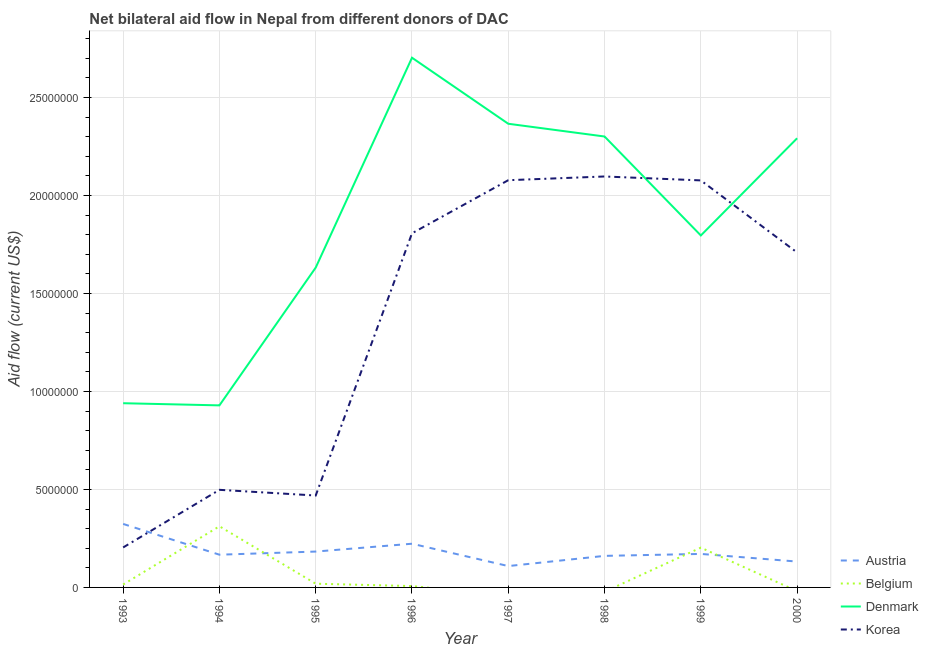How many different coloured lines are there?
Provide a succinct answer. 4. Does the line corresponding to amount of aid given by korea intersect with the line corresponding to amount of aid given by denmark?
Your answer should be compact. Yes. Is the number of lines equal to the number of legend labels?
Offer a terse response. No. What is the amount of aid given by korea in 1998?
Keep it short and to the point. 2.10e+07. Across all years, what is the maximum amount of aid given by belgium?
Provide a short and direct response. 3.12e+06. Across all years, what is the minimum amount of aid given by korea?
Make the answer very short. 2.04e+06. What is the total amount of aid given by austria in the graph?
Give a very brief answer. 1.47e+07. What is the difference between the amount of aid given by denmark in 1993 and that in 1999?
Your response must be concise. -8.56e+06. What is the difference between the amount of aid given by belgium in 1996 and the amount of aid given by austria in 1995?
Keep it short and to the point. -1.76e+06. What is the average amount of aid given by denmark per year?
Provide a succinct answer. 1.87e+07. In the year 1995, what is the difference between the amount of aid given by denmark and amount of aid given by austria?
Keep it short and to the point. 1.45e+07. What is the ratio of the amount of aid given by austria in 1998 to that in 2000?
Offer a very short reply. 1.22. Is the difference between the amount of aid given by denmark in 1998 and 1999 greater than the difference between the amount of aid given by austria in 1998 and 1999?
Your answer should be very brief. Yes. What is the difference between the highest and the second highest amount of aid given by denmark?
Give a very brief answer. 3.37e+06. What is the difference between the highest and the lowest amount of aid given by denmark?
Your answer should be compact. 1.77e+07. In how many years, is the amount of aid given by austria greater than the average amount of aid given by austria taken over all years?
Offer a terse response. 2. Is the sum of the amount of aid given by denmark in 1994 and 1998 greater than the maximum amount of aid given by belgium across all years?
Keep it short and to the point. Yes. Is the amount of aid given by belgium strictly less than the amount of aid given by korea over the years?
Provide a succinct answer. Yes. How many lines are there?
Offer a terse response. 4. How many years are there in the graph?
Offer a very short reply. 8. What is the difference between two consecutive major ticks on the Y-axis?
Give a very brief answer. 5.00e+06. Does the graph contain any zero values?
Provide a succinct answer. Yes. Does the graph contain grids?
Your response must be concise. Yes. Where does the legend appear in the graph?
Offer a terse response. Bottom right. How many legend labels are there?
Keep it short and to the point. 4. How are the legend labels stacked?
Provide a succinct answer. Vertical. What is the title of the graph?
Ensure brevity in your answer.  Net bilateral aid flow in Nepal from different donors of DAC. What is the label or title of the X-axis?
Offer a terse response. Year. What is the label or title of the Y-axis?
Provide a succinct answer. Aid flow (current US$). What is the Aid flow (current US$) in Austria in 1993?
Your answer should be compact. 3.24e+06. What is the Aid flow (current US$) of Denmark in 1993?
Provide a succinct answer. 9.40e+06. What is the Aid flow (current US$) in Korea in 1993?
Your answer should be compact. 2.04e+06. What is the Aid flow (current US$) of Austria in 1994?
Offer a very short reply. 1.67e+06. What is the Aid flow (current US$) in Belgium in 1994?
Your answer should be compact. 3.12e+06. What is the Aid flow (current US$) in Denmark in 1994?
Provide a short and direct response. 9.29e+06. What is the Aid flow (current US$) in Korea in 1994?
Provide a short and direct response. 4.98e+06. What is the Aid flow (current US$) in Austria in 1995?
Offer a terse response. 1.83e+06. What is the Aid flow (current US$) of Denmark in 1995?
Provide a short and direct response. 1.63e+07. What is the Aid flow (current US$) of Korea in 1995?
Offer a very short reply. 4.69e+06. What is the Aid flow (current US$) of Austria in 1996?
Keep it short and to the point. 2.23e+06. What is the Aid flow (current US$) of Belgium in 1996?
Give a very brief answer. 7.00e+04. What is the Aid flow (current US$) in Denmark in 1996?
Provide a short and direct response. 2.70e+07. What is the Aid flow (current US$) in Korea in 1996?
Your answer should be very brief. 1.81e+07. What is the Aid flow (current US$) in Austria in 1997?
Provide a short and direct response. 1.09e+06. What is the Aid flow (current US$) of Denmark in 1997?
Your answer should be very brief. 2.37e+07. What is the Aid flow (current US$) of Korea in 1997?
Give a very brief answer. 2.08e+07. What is the Aid flow (current US$) of Austria in 1998?
Make the answer very short. 1.61e+06. What is the Aid flow (current US$) in Denmark in 1998?
Keep it short and to the point. 2.30e+07. What is the Aid flow (current US$) of Korea in 1998?
Your answer should be very brief. 2.10e+07. What is the Aid flow (current US$) in Austria in 1999?
Your answer should be compact. 1.71e+06. What is the Aid flow (current US$) of Belgium in 1999?
Your answer should be compact. 2.03e+06. What is the Aid flow (current US$) of Denmark in 1999?
Provide a succinct answer. 1.80e+07. What is the Aid flow (current US$) in Korea in 1999?
Provide a short and direct response. 2.08e+07. What is the Aid flow (current US$) in Austria in 2000?
Your response must be concise. 1.32e+06. What is the Aid flow (current US$) in Denmark in 2000?
Offer a very short reply. 2.29e+07. What is the Aid flow (current US$) of Korea in 2000?
Make the answer very short. 1.71e+07. Across all years, what is the maximum Aid flow (current US$) in Austria?
Ensure brevity in your answer.  3.24e+06. Across all years, what is the maximum Aid flow (current US$) in Belgium?
Your response must be concise. 3.12e+06. Across all years, what is the maximum Aid flow (current US$) of Denmark?
Ensure brevity in your answer.  2.70e+07. Across all years, what is the maximum Aid flow (current US$) of Korea?
Your response must be concise. 2.10e+07. Across all years, what is the minimum Aid flow (current US$) in Austria?
Ensure brevity in your answer.  1.09e+06. Across all years, what is the minimum Aid flow (current US$) of Denmark?
Provide a short and direct response. 9.29e+06. Across all years, what is the minimum Aid flow (current US$) of Korea?
Give a very brief answer. 2.04e+06. What is the total Aid flow (current US$) in Austria in the graph?
Provide a short and direct response. 1.47e+07. What is the total Aid flow (current US$) of Belgium in the graph?
Offer a terse response. 5.56e+06. What is the total Aid flow (current US$) in Denmark in the graph?
Your answer should be compact. 1.50e+08. What is the total Aid flow (current US$) in Korea in the graph?
Give a very brief answer. 1.09e+08. What is the difference between the Aid flow (current US$) of Austria in 1993 and that in 1994?
Offer a very short reply. 1.57e+06. What is the difference between the Aid flow (current US$) in Belgium in 1993 and that in 1994?
Make the answer very short. -2.97e+06. What is the difference between the Aid flow (current US$) in Denmark in 1993 and that in 1994?
Provide a short and direct response. 1.10e+05. What is the difference between the Aid flow (current US$) in Korea in 1993 and that in 1994?
Keep it short and to the point. -2.94e+06. What is the difference between the Aid flow (current US$) of Austria in 1993 and that in 1995?
Ensure brevity in your answer.  1.41e+06. What is the difference between the Aid flow (current US$) of Belgium in 1993 and that in 1995?
Offer a very short reply. -4.00e+04. What is the difference between the Aid flow (current US$) of Denmark in 1993 and that in 1995?
Give a very brief answer. -6.92e+06. What is the difference between the Aid flow (current US$) of Korea in 1993 and that in 1995?
Keep it short and to the point. -2.65e+06. What is the difference between the Aid flow (current US$) of Austria in 1993 and that in 1996?
Your answer should be very brief. 1.01e+06. What is the difference between the Aid flow (current US$) of Denmark in 1993 and that in 1996?
Make the answer very short. -1.76e+07. What is the difference between the Aid flow (current US$) of Korea in 1993 and that in 1996?
Ensure brevity in your answer.  -1.60e+07. What is the difference between the Aid flow (current US$) of Austria in 1993 and that in 1997?
Offer a terse response. 2.15e+06. What is the difference between the Aid flow (current US$) in Denmark in 1993 and that in 1997?
Your answer should be very brief. -1.43e+07. What is the difference between the Aid flow (current US$) in Korea in 1993 and that in 1997?
Provide a succinct answer. -1.87e+07. What is the difference between the Aid flow (current US$) in Austria in 1993 and that in 1998?
Your response must be concise. 1.63e+06. What is the difference between the Aid flow (current US$) of Denmark in 1993 and that in 1998?
Your response must be concise. -1.36e+07. What is the difference between the Aid flow (current US$) in Korea in 1993 and that in 1998?
Give a very brief answer. -1.89e+07. What is the difference between the Aid flow (current US$) in Austria in 1993 and that in 1999?
Your answer should be very brief. 1.53e+06. What is the difference between the Aid flow (current US$) of Belgium in 1993 and that in 1999?
Your answer should be compact. -1.88e+06. What is the difference between the Aid flow (current US$) in Denmark in 1993 and that in 1999?
Give a very brief answer. -8.56e+06. What is the difference between the Aid flow (current US$) of Korea in 1993 and that in 1999?
Provide a succinct answer. -1.87e+07. What is the difference between the Aid flow (current US$) of Austria in 1993 and that in 2000?
Your answer should be compact. 1.92e+06. What is the difference between the Aid flow (current US$) of Denmark in 1993 and that in 2000?
Offer a very short reply. -1.35e+07. What is the difference between the Aid flow (current US$) in Korea in 1993 and that in 2000?
Ensure brevity in your answer.  -1.50e+07. What is the difference between the Aid flow (current US$) of Austria in 1994 and that in 1995?
Your answer should be compact. -1.60e+05. What is the difference between the Aid flow (current US$) of Belgium in 1994 and that in 1995?
Ensure brevity in your answer.  2.93e+06. What is the difference between the Aid flow (current US$) in Denmark in 1994 and that in 1995?
Provide a short and direct response. -7.03e+06. What is the difference between the Aid flow (current US$) in Austria in 1994 and that in 1996?
Give a very brief answer. -5.60e+05. What is the difference between the Aid flow (current US$) of Belgium in 1994 and that in 1996?
Provide a short and direct response. 3.05e+06. What is the difference between the Aid flow (current US$) of Denmark in 1994 and that in 1996?
Make the answer very short. -1.77e+07. What is the difference between the Aid flow (current US$) of Korea in 1994 and that in 1996?
Your answer should be compact. -1.31e+07. What is the difference between the Aid flow (current US$) in Austria in 1994 and that in 1997?
Ensure brevity in your answer.  5.80e+05. What is the difference between the Aid flow (current US$) in Denmark in 1994 and that in 1997?
Make the answer very short. -1.44e+07. What is the difference between the Aid flow (current US$) of Korea in 1994 and that in 1997?
Provide a short and direct response. -1.58e+07. What is the difference between the Aid flow (current US$) in Denmark in 1994 and that in 1998?
Ensure brevity in your answer.  -1.37e+07. What is the difference between the Aid flow (current US$) in Korea in 1994 and that in 1998?
Make the answer very short. -1.60e+07. What is the difference between the Aid flow (current US$) in Belgium in 1994 and that in 1999?
Give a very brief answer. 1.09e+06. What is the difference between the Aid flow (current US$) in Denmark in 1994 and that in 1999?
Your response must be concise. -8.67e+06. What is the difference between the Aid flow (current US$) of Korea in 1994 and that in 1999?
Ensure brevity in your answer.  -1.58e+07. What is the difference between the Aid flow (current US$) in Denmark in 1994 and that in 2000?
Give a very brief answer. -1.36e+07. What is the difference between the Aid flow (current US$) of Korea in 1994 and that in 2000?
Keep it short and to the point. -1.21e+07. What is the difference between the Aid flow (current US$) of Austria in 1995 and that in 1996?
Provide a short and direct response. -4.00e+05. What is the difference between the Aid flow (current US$) in Belgium in 1995 and that in 1996?
Give a very brief answer. 1.20e+05. What is the difference between the Aid flow (current US$) of Denmark in 1995 and that in 1996?
Keep it short and to the point. -1.07e+07. What is the difference between the Aid flow (current US$) in Korea in 1995 and that in 1996?
Keep it short and to the point. -1.34e+07. What is the difference between the Aid flow (current US$) of Austria in 1995 and that in 1997?
Your answer should be compact. 7.40e+05. What is the difference between the Aid flow (current US$) in Denmark in 1995 and that in 1997?
Your answer should be very brief. -7.34e+06. What is the difference between the Aid flow (current US$) in Korea in 1995 and that in 1997?
Offer a terse response. -1.61e+07. What is the difference between the Aid flow (current US$) of Denmark in 1995 and that in 1998?
Offer a very short reply. -6.69e+06. What is the difference between the Aid flow (current US$) in Korea in 1995 and that in 1998?
Your answer should be very brief. -1.63e+07. What is the difference between the Aid flow (current US$) in Austria in 1995 and that in 1999?
Your answer should be very brief. 1.20e+05. What is the difference between the Aid flow (current US$) in Belgium in 1995 and that in 1999?
Your answer should be compact. -1.84e+06. What is the difference between the Aid flow (current US$) of Denmark in 1995 and that in 1999?
Offer a very short reply. -1.64e+06. What is the difference between the Aid flow (current US$) of Korea in 1995 and that in 1999?
Provide a short and direct response. -1.61e+07. What is the difference between the Aid flow (current US$) of Austria in 1995 and that in 2000?
Ensure brevity in your answer.  5.10e+05. What is the difference between the Aid flow (current US$) in Denmark in 1995 and that in 2000?
Offer a terse response. -6.60e+06. What is the difference between the Aid flow (current US$) in Korea in 1995 and that in 2000?
Keep it short and to the point. -1.24e+07. What is the difference between the Aid flow (current US$) of Austria in 1996 and that in 1997?
Your answer should be compact. 1.14e+06. What is the difference between the Aid flow (current US$) in Denmark in 1996 and that in 1997?
Your answer should be compact. 3.37e+06. What is the difference between the Aid flow (current US$) in Korea in 1996 and that in 1997?
Provide a succinct answer. -2.71e+06. What is the difference between the Aid flow (current US$) in Austria in 1996 and that in 1998?
Your response must be concise. 6.20e+05. What is the difference between the Aid flow (current US$) in Denmark in 1996 and that in 1998?
Ensure brevity in your answer.  4.02e+06. What is the difference between the Aid flow (current US$) in Korea in 1996 and that in 1998?
Offer a terse response. -2.90e+06. What is the difference between the Aid flow (current US$) of Austria in 1996 and that in 1999?
Your answer should be compact. 5.20e+05. What is the difference between the Aid flow (current US$) of Belgium in 1996 and that in 1999?
Ensure brevity in your answer.  -1.96e+06. What is the difference between the Aid flow (current US$) of Denmark in 1996 and that in 1999?
Offer a very short reply. 9.07e+06. What is the difference between the Aid flow (current US$) of Korea in 1996 and that in 1999?
Ensure brevity in your answer.  -2.70e+06. What is the difference between the Aid flow (current US$) of Austria in 1996 and that in 2000?
Provide a short and direct response. 9.10e+05. What is the difference between the Aid flow (current US$) in Denmark in 1996 and that in 2000?
Provide a succinct answer. 4.11e+06. What is the difference between the Aid flow (current US$) in Korea in 1996 and that in 2000?
Offer a very short reply. 9.80e+05. What is the difference between the Aid flow (current US$) of Austria in 1997 and that in 1998?
Offer a terse response. -5.20e+05. What is the difference between the Aid flow (current US$) in Denmark in 1997 and that in 1998?
Offer a very short reply. 6.50e+05. What is the difference between the Aid flow (current US$) in Korea in 1997 and that in 1998?
Give a very brief answer. -1.90e+05. What is the difference between the Aid flow (current US$) in Austria in 1997 and that in 1999?
Offer a very short reply. -6.20e+05. What is the difference between the Aid flow (current US$) of Denmark in 1997 and that in 1999?
Your response must be concise. 5.70e+06. What is the difference between the Aid flow (current US$) of Denmark in 1997 and that in 2000?
Offer a very short reply. 7.40e+05. What is the difference between the Aid flow (current US$) in Korea in 1997 and that in 2000?
Make the answer very short. 3.69e+06. What is the difference between the Aid flow (current US$) in Denmark in 1998 and that in 1999?
Provide a succinct answer. 5.05e+06. What is the difference between the Aid flow (current US$) of Korea in 1998 and that in 1999?
Your response must be concise. 2.00e+05. What is the difference between the Aid flow (current US$) of Denmark in 1998 and that in 2000?
Offer a terse response. 9.00e+04. What is the difference between the Aid flow (current US$) in Korea in 1998 and that in 2000?
Your answer should be very brief. 3.88e+06. What is the difference between the Aid flow (current US$) of Austria in 1999 and that in 2000?
Your answer should be compact. 3.90e+05. What is the difference between the Aid flow (current US$) of Denmark in 1999 and that in 2000?
Your answer should be compact. -4.96e+06. What is the difference between the Aid flow (current US$) in Korea in 1999 and that in 2000?
Make the answer very short. 3.68e+06. What is the difference between the Aid flow (current US$) in Austria in 1993 and the Aid flow (current US$) in Denmark in 1994?
Provide a succinct answer. -6.05e+06. What is the difference between the Aid flow (current US$) of Austria in 1993 and the Aid flow (current US$) of Korea in 1994?
Provide a succinct answer. -1.74e+06. What is the difference between the Aid flow (current US$) of Belgium in 1993 and the Aid flow (current US$) of Denmark in 1994?
Provide a succinct answer. -9.14e+06. What is the difference between the Aid flow (current US$) in Belgium in 1993 and the Aid flow (current US$) in Korea in 1994?
Offer a terse response. -4.83e+06. What is the difference between the Aid flow (current US$) of Denmark in 1993 and the Aid flow (current US$) of Korea in 1994?
Provide a short and direct response. 4.42e+06. What is the difference between the Aid flow (current US$) in Austria in 1993 and the Aid flow (current US$) in Belgium in 1995?
Provide a succinct answer. 3.05e+06. What is the difference between the Aid flow (current US$) in Austria in 1993 and the Aid flow (current US$) in Denmark in 1995?
Offer a very short reply. -1.31e+07. What is the difference between the Aid flow (current US$) in Austria in 1993 and the Aid flow (current US$) in Korea in 1995?
Offer a terse response. -1.45e+06. What is the difference between the Aid flow (current US$) of Belgium in 1993 and the Aid flow (current US$) of Denmark in 1995?
Make the answer very short. -1.62e+07. What is the difference between the Aid flow (current US$) of Belgium in 1993 and the Aid flow (current US$) of Korea in 1995?
Ensure brevity in your answer.  -4.54e+06. What is the difference between the Aid flow (current US$) in Denmark in 1993 and the Aid flow (current US$) in Korea in 1995?
Your answer should be compact. 4.71e+06. What is the difference between the Aid flow (current US$) in Austria in 1993 and the Aid flow (current US$) in Belgium in 1996?
Your answer should be very brief. 3.17e+06. What is the difference between the Aid flow (current US$) of Austria in 1993 and the Aid flow (current US$) of Denmark in 1996?
Provide a short and direct response. -2.38e+07. What is the difference between the Aid flow (current US$) in Austria in 1993 and the Aid flow (current US$) in Korea in 1996?
Your answer should be very brief. -1.48e+07. What is the difference between the Aid flow (current US$) in Belgium in 1993 and the Aid flow (current US$) in Denmark in 1996?
Your answer should be compact. -2.69e+07. What is the difference between the Aid flow (current US$) of Belgium in 1993 and the Aid flow (current US$) of Korea in 1996?
Ensure brevity in your answer.  -1.79e+07. What is the difference between the Aid flow (current US$) in Denmark in 1993 and the Aid flow (current US$) in Korea in 1996?
Offer a terse response. -8.67e+06. What is the difference between the Aid flow (current US$) of Austria in 1993 and the Aid flow (current US$) of Denmark in 1997?
Provide a short and direct response. -2.04e+07. What is the difference between the Aid flow (current US$) in Austria in 1993 and the Aid flow (current US$) in Korea in 1997?
Give a very brief answer. -1.75e+07. What is the difference between the Aid flow (current US$) of Belgium in 1993 and the Aid flow (current US$) of Denmark in 1997?
Ensure brevity in your answer.  -2.35e+07. What is the difference between the Aid flow (current US$) of Belgium in 1993 and the Aid flow (current US$) of Korea in 1997?
Your answer should be very brief. -2.06e+07. What is the difference between the Aid flow (current US$) of Denmark in 1993 and the Aid flow (current US$) of Korea in 1997?
Offer a terse response. -1.14e+07. What is the difference between the Aid flow (current US$) in Austria in 1993 and the Aid flow (current US$) in Denmark in 1998?
Offer a very short reply. -1.98e+07. What is the difference between the Aid flow (current US$) of Austria in 1993 and the Aid flow (current US$) of Korea in 1998?
Your answer should be compact. -1.77e+07. What is the difference between the Aid flow (current US$) in Belgium in 1993 and the Aid flow (current US$) in Denmark in 1998?
Give a very brief answer. -2.29e+07. What is the difference between the Aid flow (current US$) of Belgium in 1993 and the Aid flow (current US$) of Korea in 1998?
Your answer should be compact. -2.08e+07. What is the difference between the Aid flow (current US$) in Denmark in 1993 and the Aid flow (current US$) in Korea in 1998?
Your answer should be compact. -1.16e+07. What is the difference between the Aid flow (current US$) in Austria in 1993 and the Aid flow (current US$) in Belgium in 1999?
Your response must be concise. 1.21e+06. What is the difference between the Aid flow (current US$) of Austria in 1993 and the Aid flow (current US$) of Denmark in 1999?
Make the answer very short. -1.47e+07. What is the difference between the Aid flow (current US$) of Austria in 1993 and the Aid flow (current US$) of Korea in 1999?
Your response must be concise. -1.75e+07. What is the difference between the Aid flow (current US$) in Belgium in 1993 and the Aid flow (current US$) in Denmark in 1999?
Your response must be concise. -1.78e+07. What is the difference between the Aid flow (current US$) of Belgium in 1993 and the Aid flow (current US$) of Korea in 1999?
Provide a succinct answer. -2.06e+07. What is the difference between the Aid flow (current US$) of Denmark in 1993 and the Aid flow (current US$) of Korea in 1999?
Your answer should be compact. -1.14e+07. What is the difference between the Aid flow (current US$) of Austria in 1993 and the Aid flow (current US$) of Denmark in 2000?
Make the answer very short. -1.97e+07. What is the difference between the Aid flow (current US$) in Austria in 1993 and the Aid flow (current US$) in Korea in 2000?
Ensure brevity in your answer.  -1.38e+07. What is the difference between the Aid flow (current US$) in Belgium in 1993 and the Aid flow (current US$) in Denmark in 2000?
Offer a very short reply. -2.28e+07. What is the difference between the Aid flow (current US$) of Belgium in 1993 and the Aid flow (current US$) of Korea in 2000?
Offer a terse response. -1.69e+07. What is the difference between the Aid flow (current US$) of Denmark in 1993 and the Aid flow (current US$) of Korea in 2000?
Give a very brief answer. -7.69e+06. What is the difference between the Aid flow (current US$) of Austria in 1994 and the Aid flow (current US$) of Belgium in 1995?
Your response must be concise. 1.48e+06. What is the difference between the Aid flow (current US$) of Austria in 1994 and the Aid flow (current US$) of Denmark in 1995?
Your answer should be compact. -1.46e+07. What is the difference between the Aid flow (current US$) of Austria in 1994 and the Aid flow (current US$) of Korea in 1995?
Provide a short and direct response. -3.02e+06. What is the difference between the Aid flow (current US$) of Belgium in 1994 and the Aid flow (current US$) of Denmark in 1995?
Offer a very short reply. -1.32e+07. What is the difference between the Aid flow (current US$) in Belgium in 1994 and the Aid flow (current US$) in Korea in 1995?
Offer a terse response. -1.57e+06. What is the difference between the Aid flow (current US$) of Denmark in 1994 and the Aid flow (current US$) of Korea in 1995?
Ensure brevity in your answer.  4.60e+06. What is the difference between the Aid flow (current US$) of Austria in 1994 and the Aid flow (current US$) of Belgium in 1996?
Give a very brief answer. 1.60e+06. What is the difference between the Aid flow (current US$) in Austria in 1994 and the Aid flow (current US$) in Denmark in 1996?
Offer a very short reply. -2.54e+07. What is the difference between the Aid flow (current US$) in Austria in 1994 and the Aid flow (current US$) in Korea in 1996?
Keep it short and to the point. -1.64e+07. What is the difference between the Aid flow (current US$) of Belgium in 1994 and the Aid flow (current US$) of Denmark in 1996?
Your answer should be very brief. -2.39e+07. What is the difference between the Aid flow (current US$) of Belgium in 1994 and the Aid flow (current US$) of Korea in 1996?
Ensure brevity in your answer.  -1.50e+07. What is the difference between the Aid flow (current US$) in Denmark in 1994 and the Aid flow (current US$) in Korea in 1996?
Provide a succinct answer. -8.78e+06. What is the difference between the Aid flow (current US$) of Austria in 1994 and the Aid flow (current US$) of Denmark in 1997?
Keep it short and to the point. -2.20e+07. What is the difference between the Aid flow (current US$) of Austria in 1994 and the Aid flow (current US$) of Korea in 1997?
Keep it short and to the point. -1.91e+07. What is the difference between the Aid flow (current US$) of Belgium in 1994 and the Aid flow (current US$) of Denmark in 1997?
Make the answer very short. -2.05e+07. What is the difference between the Aid flow (current US$) of Belgium in 1994 and the Aid flow (current US$) of Korea in 1997?
Keep it short and to the point. -1.77e+07. What is the difference between the Aid flow (current US$) in Denmark in 1994 and the Aid flow (current US$) in Korea in 1997?
Provide a succinct answer. -1.15e+07. What is the difference between the Aid flow (current US$) of Austria in 1994 and the Aid flow (current US$) of Denmark in 1998?
Offer a very short reply. -2.13e+07. What is the difference between the Aid flow (current US$) of Austria in 1994 and the Aid flow (current US$) of Korea in 1998?
Provide a succinct answer. -1.93e+07. What is the difference between the Aid flow (current US$) in Belgium in 1994 and the Aid flow (current US$) in Denmark in 1998?
Make the answer very short. -1.99e+07. What is the difference between the Aid flow (current US$) in Belgium in 1994 and the Aid flow (current US$) in Korea in 1998?
Give a very brief answer. -1.78e+07. What is the difference between the Aid flow (current US$) of Denmark in 1994 and the Aid flow (current US$) of Korea in 1998?
Make the answer very short. -1.17e+07. What is the difference between the Aid flow (current US$) in Austria in 1994 and the Aid flow (current US$) in Belgium in 1999?
Offer a very short reply. -3.60e+05. What is the difference between the Aid flow (current US$) of Austria in 1994 and the Aid flow (current US$) of Denmark in 1999?
Your response must be concise. -1.63e+07. What is the difference between the Aid flow (current US$) of Austria in 1994 and the Aid flow (current US$) of Korea in 1999?
Provide a succinct answer. -1.91e+07. What is the difference between the Aid flow (current US$) of Belgium in 1994 and the Aid flow (current US$) of Denmark in 1999?
Make the answer very short. -1.48e+07. What is the difference between the Aid flow (current US$) in Belgium in 1994 and the Aid flow (current US$) in Korea in 1999?
Offer a terse response. -1.76e+07. What is the difference between the Aid flow (current US$) of Denmark in 1994 and the Aid flow (current US$) of Korea in 1999?
Your response must be concise. -1.15e+07. What is the difference between the Aid flow (current US$) of Austria in 1994 and the Aid flow (current US$) of Denmark in 2000?
Offer a terse response. -2.12e+07. What is the difference between the Aid flow (current US$) in Austria in 1994 and the Aid flow (current US$) in Korea in 2000?
Provide a short and direct response. -1.54e+07. What is the difference between the Aid flow (current US$) in Belgium in 1994 and the Aid flow (current US$) in Denmark in 2000?
Give a very brief answer. -1.98e+07. What is the difference between the Aid flow (current US$) in Belgium in 1994 and the Aid flow (current US$) in Korea in 2000?
Give a very brief answer. -1.40e+07. What is the difference between the Aid flow (current US$) of Denmark in 1994 and the Aid flow (current US$) of Korea in 2000?
Offer a very short reply. -7.80e+06. What is the difference between the Aid flow (current US$) in Austria in 1995 and the Aid flow (current US$) in Belgium in 1996?
Offer a terse response. 1.76e+06. What is the difference between the Aid flow (current US$) in Austria in 1995 and the Aid flow (current US$) in Denmark in 1996?
Your answer should be compact. -2.52e+07. What is the difference between the Aid flow (current US$) of Austria in 1995 and the Aid flow (current US$) of Korea in 1996?
Make the answer very short. -1.62e+07. What is the difference between the Aid flow (current US$) of Belgium in 1995 and the Aid flow (current US$) of Denmark in 1996?
Your answer should be very brief. -2.68e+07. What is the difference between the Aid flow (current US$) of Belgium in 1995 and the Aid flow (current US$) of Korea in 1996?
Make the answer very short. -1.79e+07. What is the difference between the Aid flow (current US$) in Denmark in 1995 and the Aid flow (current US$) in Korea in 1996?
Offer a terse response. -1.75e+06. What is the difference between the Aid flow (current US$) in Austria in 1995 and the Aid flow (current US$) in Denmark in 1997?
Offer a very short reply. -2.18e+07. What is the difference between the Aid flow (current US$) in Austria in 1995 and the Aid flow (current US$) in Korea in 1997?
Offer a terse response. -1.90e+07. What is the difference between the Aid flow (current US$) in Belgium in 1995 and the Aid flow (current US$) in Denmark in 1997?
Your answer should be compact. -2.35e+07. What is the difference between the Aid flow (current US$) in Belgium in 1995 and the Aid flow (current US$) in Korea in 1997?
Keep it short and to the point. -2.06e+07. What is the difference between the Aid flow (current US$) of Denmark in 1995 and the Aid flow (current US$) of Korea in 1997?
Provide a succinct answer. -4.46e+06. What is the difference between the Aid flow (current US$) in Austria in 1995 and the Aid flow (current US$) in Denmark in 1998?
Ensure brevity in your answer.  -2.12e+07. What is the difference between the Aid flow (current US$) of Austria in 1995 and the Aid flow (current US$) of Korea in 1998?
Provide a succinct answer. -1.91e+07. What is the difference between the Aid flow (current US$) of Belgium in 1995 and the Aid flow (current US$) of Denmark in 1998?
Keep it short and to the point. -2.28e+07. What is the difference between the Aid flow (current US$) in Belgium in 1995 and the Aid flow (current US$) in Korea in 1998?
Keep it short and to the point. -2.08e+07. What is the difference between the Aid flow (current US$) in Denmark in 1995 and the Aid flow (current US$) in Korea in 1998?
Your answer should be compact. -4.65e+06. What is the difference between the Aid flow (current US$) in Austria in 1995 and the Aid flow (current US$) in Denmark in 1999?
Give a very brief answer. -1.61e+07. What is the difference between the Aid flow (current US$) in Austria in 1995 and the Aid flow (current US$) in Korea in 1999?
Make the answer very short. -1.89e+07. What is the difference between the Aid flow (current US$) of Belgium in 1995 and the Aid flow (current US$) of Denmark in 1999?
Ensure brevity in your answer.  -1.78e+07. What is the difference between the Aid flow (current US$) in Belgium in 1995 and the Aid flow (current US$) in Korea in 1999?
Offer a terse response. -2.06e+07. What is the difference between the Aid flow (current US$) in Denmark in 1995 and the Aid flow (current US$) in Korea in 1999?
Your response must be concise. -4.45e+06. What is the difference between the Aid flow (current US$) of Austria in 1995 and the Aid flow (current US$) of Denmark in 2000?
Keep it short and to the point. -2.11e+07. What is the difference between the Aid flow (current US$) of Austria in 1995 and the Aid flow (current US$) of Korea in 2000?
Your answer should be compact. -1.53e+07. What is the difference between the Aid flow (current US$) in Belgium in 1995 and the Aid flow (current US$) in Denmark in 2000?
Offer a terse response. -2.27e+07. What is the difference between the Aid flow (current US$) of Belgium in 1995 and the Aid flow (current US$) of Korea in 2000?
Your response must be concise. -1.69e+07. What is the difference between the Aid flow (current US$) in Denmark in 1995 and the Aid flow (current US$) in Korea in 2000?
Make the answer very short. -7.70e+05. What is the difference between the Aid flow (current US$) of Austria in 1996 and the Aid flow (current US$) of Denmark in 1997?
Your answer should be compact. -2.14e+07. What is the difference between the Aid flow (current US$) of Austria in 1996 and the Aid flow (current US$) of Korea in 1997?
Keep it short and to the point. -1.86e+07. What is the difference between the Aid flow (current US$) in Belgium in 1996 and the Aid flow (current US$) in Denmark in 1997?
Your response must be concise. -2.36e+07. What is the difference between the Aid flow (current US$) in Belgium in 1996 and the Aid flow (current US$) in Korea in 1997?
Give a very brief answer. -2.07e+07. What is the difference between the Aid flow (current US$) in Denmark in 1996 and the Aid flow (current US$) in Korea in 1997?
Offer a terse response. 6.25e+06. What is the difference between the Aid flow (current US$) in Austria in 1996 and the Aid flow (current US$) in Denmark in 1998?
Your answer should be compact. -2.08e+07. What is the difference between the Aid flow (current US$) of Austria in 1996 and the Aid flow (current US$) of Korea in 1998?
Make the answer very short. -1.87e+07. What is the difference between the Aid flow (current US$) of Belgium in 1996 and the Aid flow (current US$) of Denmark in 1998?
Keep it short and to the point. -2.29e+07. What is the difference between the Aid flow (current US$) in Belgium in 1996 and the Aid flow (current US$) in Korea in 1998?
Give a very brief answer. -2.09e+07. What is the difference between the Aid flow (current US$) in Denmark in 1996 and the Aid flow (current US$) in Korea in 1998?
Your response must be concise. 6.06e+06. What is the difference between the Aid flow (current US$) of Austria in 1996 and the Aid flow (current US$) of Denmark in 1999?
Offer a terse response. -1.57e+07. What is the difference between the Aid flow (current US$) of Austria in 1996 and the Aid flow (current US$) of Korea in 1999?
Offer a very short reply. -1.85e+07. What is the difference between the Aid flow (current US$) of Belgium in 1996 and the Aid flow (current US$) of Denmark in 1999?
Ensure brevity in your answer.  -1.79e+07. What is the difference between the Aid flow (current US$) in Belgium in 1996 and the Aid flow (current US$) in Korea in 1999?
Keep it short and to the point. -2.07e+07. What is the difference between the Aid flow (current US$) in Denmark in 1996 and the Aid flow (current US$) in Korea in 1999?
Give a very brief answer. 6.26e+06. What is the difference between the Aid flow (current US$) of Austria in 1996 and the Aid flow (current US$) of Denmark in 2000?
Keep it short and to the point. -2.07e+07. What is the difference between the Aid flow (current US$) in Austria in 1996 and the Aid flow (current US$) in Korea in 2000?
Ensure brevity in your answer.  -1.49e+07. What is the difference between the Aid flow (current US$) in Belgium in 1996 and the Aid flow (current US$) in Denmark in 2000?
Your answer should be very brief. -2.28e+07. What is the difference between the Aid flow (current US$) in Belgium in 1996 and the Aid flow (current US$) in Korea in 2000?
Give a very brief answer. -1.70e+07. What is the difference between the Aid flow (current US$) in Denmark in 1996 and the Aid flow (current US$) in Korea in 2000?
Keep it short and to the point. 9.94e+06. What is the difference between the Aid flow (current US$) of Austria in 1997 and the Aid flow (current US$) of Denmark in 1998?
Give a very brief answer. -2.19e+07. What is the difference between the Aid flow (current US$) of Austria in 1997 and the Aid flow (current US$) of Korea in 1998?
Your answer should be very brief. -1.99e+07. What is the difference between the Aid flow (current US$) in Denmark in 1997 and the Aid flow (current US$) in Korea in 1998?
Your answer should be very brief. 2.69e+06. What is the difference between the Aid flow (current US$) of Austria in 1997 and the Aid flow (current US$) of Belgium in 1999?
Offer a very short reply. -9.40e+05. What is the difference between the Aid flow (current US$) in Austria in 1997 and the Aid flow (current US$) in Denmark in 1999?
Make the answer very short. -1.69e+07. What is the difference between the Aid flow (current US$) in Austria in 1997 and the Aid flow (current US$) in Korea in 1999?
Keep it short and to the point. -1.97e+07. What is the difference between the Aid flow (current US$) in Denmark in 1997 and the Aid flow (current US$) in Korea in 1999?
Give a very brief answer. 2.89e+06. What is the difference between the Aid flow (current US$) in Austria in 1997 and the Aid flow (current US$) in Denmark in 2000?
Offer a very short reply. -2.18e+07. What is the difference between the Aid flow (current US$) of Austria in 1997 and the Aid flow (current US$) of Korea in 2000?
Keep it short and to the point. -1.60e+07. What is the difference between the Aid flow (current US$) in Denmark in 1997 and the Aid flow (current US$) in Korea in 2000?
Ensure brevity in your answer.  6.57e+06. What is the difference between the Aid flow (current US$) of Austria in 1998 and the Aid flow (current US$) of Belgium in 1999?
Make the answer very short. -4.20e+05. What is the difference between the Aid flow (current US$) of Austria in 1998 and the Aid flow (current US$) of Denmark in 1999?
Give a very brief answer. -1.64e+07. What is the difference between the Aid flow (current US$) in Austria in 1998 and the Aid flow (current US$) in Korea in 1999?
Provide a short and direct response. -1.92e+07. What is the difference between the Aid flow (current US$) of Denmark in 1998 and the Aid flow (current US$) of Korea in 1999?
Make the answer very short. 2.24e+06. What is the difference between the Aid flow (current US$) in Austria in 1998 and the Aid flow (current US$) in Denmark in 2000?
Your answer should be compact. -2.13e+07. What is the difference between the Aid flow (current US$) in Austria in 1998 and the Aid flow (current US$) in Korea in 2000?
Provide a short and direct response. -1.55e+07. What is the difference between the Aid flow (current US$) in Denmark in 1998 and the Aid flow (current US$) in Korea in 2000?
Your answer should be compact. 5.92e+06. What is the difference between the Aid flow (current US$) of Austria in 1999 and the Aid flow (current US$) of Denmark in 2000?
Your response must be concise. -2.12e+07. What is the difference between the Aid flow (current US$) of Austria in 1999 and the Aid flow (current US$) of Korea in 2000?
Ensure brevity in your answer.  -1.54e+07. What is the difference between the Aid flow (current US$) of Belgium in 1999 and the Aid flow (current US$) of Denmark in 2000?
Your response must be concise. -2.09e+07. What is the difference between the Aid flow (current US$) in Belgium in 1999 and the Aid flow (current US$) in Korea in 2000?
Offer a very short reply. -1.51e+07. What is the difference between the Aid flow (current US$) of Denmark in 1999 and the Aid flow (current US$) of Korea in 2000?
Your answer should be compact. 8.70e+05. What is the average Aid flow (current US$) of Austria per year?
Your answer should be very brief. 1.84e+06. What is the average Aid flow (current US$) in Belgium per year?
Make the answer very short. 6.95e+05. What is the average Aid flow (current US$) in Denmark per year?
Your answer should be very brief. 1.87e+07. What is the average Aid flow (current US$) of Korea per year?
Ensure brevity in your answer.  1.37e+07. In the year 1993, what is the difference between the Aid flow (current US$) of Austria and Aid flow (current US$) of Belgium?
Your answer should be very brief. 3.09e+06. In the year 1993, what is the difference between the Aid flow (current US$) in Austria and Aid flow (current US$) in Denmark?
Offer a terse response. -6.16e+06. In the year 1993, what is the difference between the Aid flow (current US$) in Austria and Aid flow (current US$) in Korea?
Your answer should be compact. 1.20e+06. In the year 1993, what is the difference between the Aid flow (current US$) of Belgium and Aid flow (current US$) of Denmark?
Your answer should be compact. -9.25e+06. In the year 1993, what is the difference between the Aid flow (current US$) of Belgium and Aid flow (current US$) of Korea?
Keep it short and to the point. -1.89e+06. In the year 1993, what is the difference between the Aid flow (current US$) of Denmark and Aid flow (current US$) of Korea?
Provide a succinct answer. 7.36e+06. In the year 1994, what is the difference between the Aid flow (current US$) of Austria and Aid flow (current US$) of Belgium?
Provide a short and direct response. -1.45e+06. In the year 1994, what is the difference between the Aid flow (current US$) in Austria and Aid flow (current US$) in Denmark?
Your response must be concise. -7.62e+06. In the year 1994, what is the difference between the Aid flow (current US$) in Austria and Aid flow (current US$) in Korea?
Your answer should be compact. -3.31e+06. In the year 1994, what is the difference between the Aid flow (current US$) of Belgium and Aid flow (current US$) of Denmark?
Provide a short and direct response. -6.17e+06. In the year 1994, what is the difference between the Aid flow (current US$) of Belgium and Aid flow (current US$) of Korea?
Offer a terse response. -1.86e+06. In the year 1994, what is the difference between the Aid flow (current US$) in Denmark and Aid flow (current US$) in Korea?
Your answer should be very brief. 4.31e+06. In the year 1995, what is the difference between the Aid flow (current US$) in Austria and Aid flow (current US$) in Belgium?
Provide a short and direct response. 1.64e+06. In the year 1995, what is the difference between the Aid flow (current US$) of Austria and Aid flow (current US$) of Denmark?
Provide a short and direct response. -1.45e+07. In the year 1995, what is the difference between the Aid flow (current US$) in Austria and Aid flow (current US$) in Korea?
Provide a succinct answer. -2.86e+06. In the year 1995, what is the difference between the Aid flow (current US$) of Belgium and Aid flow (current US$) of Denmark?
Give a very brief answer. -1.61e+07. In the year 1995, what is the difference between the Aid flow (current US$) of Belgium and Aid flow (current US$) of Korea?
Keep it short and to the point. -4.50e+06. In the year 1995, what is the difference between the Aid flow (current US$) of Denmark and Aid flow (current US$) of Korea?
Keep it short and to the point. 1.16e+07. In the year 1996, what is the difference between the Aid flow (current US$) of Austria and Aid flow (current US$) of Belgium?
Keep it short and to the point. 2.16e+06. In the year 1996, what is the difference between the Aid flow (current US$) in Austria and Aid flow (current US$) in Denmark?
Provide a succinct answer. -2.48e+07. In the year 1996, what is the difference between the Aid flow (current US$) in Austria and Aid flow (current US$) in Korea?
Offer a very short reply. -1.58e+07. In the year 1996, what is the difference between the Aid flow (current US$) in Belgium and Aid flow (current US$) in Denmark?
Provide a succinct answer. -2.70e+07. In the year 1996, what is the difference between the Aid flow (current US$) of Belgium and Aid flow (current US$) of Korea?
Your response must be concise. -1.80e+07. In the year 1996, what is the difference between the Aid flow (current US$) of Denmark and Aid flow (current US$) of Korea?
Make the answer very short. 8.96e+06. In the year 1997, what is the difference between the Aid flow (current US$) in Austria and Aid flow (current US$) in Denmark?
Provide a short and direct response. -2.26e+07. In the year 1997, what is the difference between the Aid flow (current US$) in Austria and Aid flow (current US$) in Korea?
Your response must be concise. -1.97e+07. In the year 1997, what is the difference between the Aid flow (current US$) in Denmark and Aid flow (current US$) in Korea?
Offer a terse response. 2.88e+06. In the year 1998, what is the difference between the Aid flow (current US$) in Austria and Aid flow (current US$) in Denmark?
Provide a short and direct response. -2.14e+07. In the year 1998, what is the difference between the Aid flow (current US$) of Austria and Aid flow (current US$) of Korea?
Offer a very short reply. -1.94e+07. In the year 1998, what is the difference between the Aid flow (current US$) in Denmark and Aid flow (current US$) in Korea?
Make the answer very short. 2.04e+06. In the year 1999, what is the difference between the Aid flow (current US$) of Austria and Aid flow (current US$) of Belgium?
Offer a very short reply. -3.20e+05. In the year 1999, what is the difference between the Aid flow (current US$) in Austria and Aid flow (current US$) in Denmark?
Keep it short and to the point. -1.62e+07. In the year 1999, what is the difference between the Aid flow (current US$) of Austria and Aid flow (current US$) of Korea?
Ensure brevity in your answer.  -1.91e+07. In the year 1999, what is the difference between the Aid flow (current US$) in Belgium and Aid flow (current US$) in Denmark?
Provide a short and direct response. -1.59e+07. In the year 1999, what is the difference between the Aid flow (current US$) in Belgium and Aid flow (current US$) in Korea?
Provide a succinct answer. -1.87e+07. In the year 1999, what is the difference between the Aid flow (current US$) of Denmark and Aid flow (current US$) of Korea?
Give a very brief answer. -2.81e+06. In the year 2000, what is the difference between the Aid flow (current US$) of Austria and Aid flow (current US$) of Denmark?
Your answer should be very brief. -2.16e+07. In the year 2000, what is the difference between the Aid flow (current US$) of Austria and Aid flow (current US$) of Korea?
Offer a very short reply. -1.58e+07. In the year 2000, what is the difference between the Aid flow (current US$) in Denmark and Aid flow (current US$) in Korea?
Provide a short and direct response. 5.83e+06. What is the ratio of the Aid flow (current US$) of Austria in 1993 to that in 1994?
Your response must be concise. 1.94. What is the ratio of the Aid flow (current US$) of Belgium in 1993 to that in 1994?
Offer a terse response. 0.05. What is the ratio of the Aid flow (current US$) in Denmark in 1993 to that in 1994?
Keep it short and to the point. 1.01. What is the ratio of the Aid flow (current US$) in Korea in 1993 to that in 1994?
Ensure brevity in your answer.  0.41. What is the ratio of the Aid flow (current US$) in Austria in 1993 to that in 1995?
Your answer should be very brief. 1.77. What is the ratio of the Aid flow (current US$) in Belgium in 1993 to that in 1995?
Your answer should be compact. 0.79. What is the ratio of the Aid flow (current US$) of Denmark in 1993 to that in 1995?
Your answer should be compact. 0.58. What is the ratio of the Aid flow (current US$) of Korea in 1993 to that in 1995?
Provide a short and direct response. 0.43. What is the ratio of the Aid flow (current US$) in Austria in 1993 to that in 1996?
Keep it short and to the point. 1.45. What is the ratio of the Aid flow (current US$) of Belgium in 1993 to that in 1996?
Offer a terse response. 2.14. What is the ratio of the Aid flow (current US$) of Denmark in 1993 to that in 1996?
Ensure brevity in your answer.  0.35. What is the ratio of the Aid flow (current US$) of Korea in 1993 to that in 1996?
Provide a short and direct response. 0.11. What is the ratio of the Aid flow (current US$) in Austria in 1993 to that in 1997?
Provide a succinct answer. 2.97. What is the ratio of the Aid flow (current US$) of Denmark in 1993 to that in 1997?
Make the answer very short. 0.4. What is the ratio of the Aid flow (current US$) of Korea in 1993 to that in 1997?
Your answer should be very brief. 0.1. What is the ratio of the Aid flow (current US$) in Austria in 1993 to that in 1998?
Ensure brevity in your answer.  2.01. What is the ratio of the Aid flow (current US$) of Denmark in 1993 to that in 1998?
Your answer should be compact. 0.41. What is the ratio of the Aid flow (current US$) in Korea in 1993 to that in 1998?
Keep it short and to the point. 0.1. What is the ratio of the Aid flow (current US$) of Austria in 1993 to that in 1999?
Your response must be concise. 1.89. What is the ratio of the Aid flow (current US$) in Belgium in 1993 to that in 1999?
Make the answer very short. 0.07. What is the ratio of the Aid flow (current US$) of Denmark in 1993 to that in 1999?
Your response must be concise. 0.52. What is the ratio of the Aid flow (current US$) of Korea in 1993 to that in 1999?
Provide a succinct answer. 0.1. What is the ratio of the Aid flow (current US$) of Austria in 1993 to that in 2000?
Ensure brevity in your answer.  2.45. What is the ratio of the Aid flow (current US$) of Denmark in 1993 to that in 2000?
Provide a short and direct response. 0.41. What is the ratio of the Aid flow (current US$) of Korea in 1993 to that in 2000?
Ensure brevity in your answer.  0.12. What is the ratio of the Aid flow (current US$) of Austria in 1994 to that in 1995?
Provide a succinct answer. 0.91. What is the ratio of the Aid flow (current US$) of Belgium in 1994 to that in 1995?
Provide a succinct answer. 16.42. What is the ratio of the Aid flow (current US$) in Denmark in 1994 to that in 1995?
Provide a succinct answer. 0.57. What is the ratio of the Aid flow (current US$) of Korea in 1994 to that in 1995?
Offer a very short reply. 1.06. What is the ratio of the Aid flow (current US$) of Austria in 1994 to that in 1996?
Provide a succinct answer. 0.75. What is the ratio of the Aid flow (current US$) of Belgium in 1994 to that in 1996?
Provide a short and direct response. 44.57. What is the ratio of the Aid flow (current US$) of Denmark in 1994 to that in 1996?
Offer a very short reply. 0.34. What is the ratio of the Aid flow (current US$) in Korea in 1994 to that in 1996?
Your answer should be compact. 0.28. What is the ratio of the Aid flow (current US$) in Austria in 1994 to that in 1997?
Offer a terse response. 1.53. What is the ratio of the Aid flow (current US$) of Denmark in 1994 to that in 1997?
Your answer should be very brief. 0.39. What is the ratio of the Aid flow (current US$) in Korea in 1994 to that in 1997?
Make the answer very short. 0.24. What is the ratio of the Aid flow (current US$) in Austria in 1994 to that in 1998?
Ensure brevity in your answer.  1.04. What is the ratio of the Aid flow (current US$) of Denmark in 1994 to that in 1998?
Your answer should be compact. 0.4. What is the ratio of the Aid flow (current US$) of Korea in 1994 to that in 1998?
Keep it short and to the point. 0.24. What is the ratio of the Aid flow (current US$) in Austria in 1994 to that in 1999?
Your response must be concise. 0.98. What is the ratio of the Aid flow (current US$) in Belgium in 1994 to that in 1999?
Your answer should be very brief. 1.54. What is the ratio of the Aid flow (current US$) in Denmark in 1994 to that in 1999?
Your response must be concise. 0.52. What is the ratio of the Aid flow (current US$) in Korea in 1994 to that in 1999?
Provide a short and direct response. 0.24. What is the ratio of the Aid flow (current US$) in Austria in 1994 to that in 2000?
Ensure brevity in your answer.  1.27. What is the ratio of the Aid flow (current US$) in Denmark in 1994 to that in 2000?
Offer a terse response. 0.41. What is the ratio of the Aid flow (current US$) in Korea in 1994 to that in 2000?
Your answer should be very brief. 0.29. What is the ratio of the Aid flow (current US$) in Austria in 1995 to that in 1996?
Make the answer very short. 0.82. What is the ratio of the Aid flow (current US$) in Belgium in 1995 to that in 1996?
Ensure brevity in your answer.  2.71. What is the ratio of the Aid flow (current US$) of Denmark in 1995 to that in 1996?
Keep it short and to the point. 0.6. What is the ratio of the Aid flow (current US$) in Korea in 1995 to that in 1996?
Your answer should be compact. 0.26. What is the ratio of the Aid flow (current US$) in Austria in 1995 to that in 1997?
Provide a succinct answer. 1.68. What is the ratio of the Aid flow (current US$) of Denmark in 1995 to that in 1997?
Give a very brief answer. 0.69. What is the ratio of the Aid flow (current US$) of Korea in 1995 to that in 1997?
Provide a short and direct response. 0.23. What is the ratio of the Aid flow (current US$) in Austria in 1995 to that in 1998?
Provide a short and direct response. 1.14. What is the ratio of the Aid flow (current US$) in Denmark in 1995 to that in 1998?
Give a very brief answer. 0.71. What is the ratio of the Aid flow (current US$) in Korea in 1995 to that in 1998?
Offer a terse response. 0.22. What is the ratio of the Aid flow (current US$) of Austria in 1995 to that in 1999?
Ensure brevity in your answer.  1.07. What is the ratio of the Aid flow (current US$) of Belgium in 1995 to that in 1999?
Ensure brevity in your answer.  0.09. What is the ratio of the Aid flow (current US$) in Denmark in 1995 to that in 1999?
Give a very brief answer. 0.91. What is the ratio of the Aid flow (current US$) of Korea in 1995 to that in 1999?
Give a very brief answer. 0.23. What is the ratio of the Aid flow (current US$) in Austria in 1995 to that in 2000?
Provide a short and direct response. 1.39. What is the ratio of the Aid flow (current US$) in Denmark in 1995 to that in 2000?
Provide a short and direct response. 0.71. What is the ratio of the Aid flow (current US$) in Korea in 1995 to that in 2000?
Give a very brief answer. 0.27. What is the ratio of the Aid flow (current US$) in Austria in 1996 to that in 1997?
Offer a terse response. 2.05. What is the ratio of the Aid flow (current US$) in Denmark in 1996 to that in 1997?
Provide a succinct answer. 1.14. What is the ratio of the Aid flow (current US$) in Korea in 1996 to that in 1997?
Your answer should be very brief. 0.87. What is the ratio of the Aid flow (current US$) of Austria in 1996 to that in 1998?
Keep it short and to the point. 1.39. What is the ratio of the Aid flow (current US$) in Denmark in 1996 to that in 1998?
Keep it short and to the point. 1.17. What is the ratio of the Aid flow (current US$) of Korea in 1996 to that in 1998?
Provide a short and direct response. 0.86. What is the ratio of the Aid flow (current US$) of Austria in 1996 to that in 1999?
Your answer should be very brief. 1.3. What is the ratio of the Aid flow (current US$) in Belgium in 1996 to that in 1999?
Make the answer very short. 0.03. What is the ratio of the Aid flow (current US$) of Denmark in 1996 to that in 1999?
Ensure brevity in your answer.  1.5. What is the ratio of the Aid flow (current US$) of Korea in 1996 to that in 1999?
Make the answer very short. 0.87. What is the ratio of the Aid flow (current US$) in Austria in 1996 to that in 2000?
Offer a very short reply. 1.69. What is the ratio of the Aid flow (current US$) of Denmark in 1996 to that in 2000?
Your response must be concise. 1.18. What is the ratio of the Aid flow (current US$) in Korea in 1996 to that in 2000?
Give a very brief answer. 1.06. What is the ratio of the Aid flow (current US$) of Austria in 1997 to that in 1998?
Offer a terse response. 0.68. What is the ratio of the Aid flow (current US$) of Denmark in 1997 to that in 1998?
Keep it short and to the point. 1.03. What is the ratio of the Aid flow (current US$) of Korea in 1997 to that in 1998?
Offer a terse response. 0.99. What is the ratio of the Aid flow (current US$) in Austria in 1997 to that in 1999?
Make the answer very short. 0.64. What is the ratio of the Aid flow (current US$) of Denmark in 1997 to that in 1999?
Provide a succinct answer. 1.32. What is the ratio of the Aid flow (current US$) of Austria in 1997 to that in 2000?
Provide a succinct answer. 0.83. What is the ratio of the Aid flow (current US$) in Denmark in 1997 to that in 2000?
Ensure brevity in your answer.  1.03. What is the ratio of the Aid flow (current US$) of Korea in 1997 to that in 2000?
Your answer should be very brief. 1.22. What is the ratio of the Aid flow (current US$) in Austria in 1998 to that in 1999?
Offer a very short reply. 0.94. What is the ratio of the Aid flow (current US$) of Denmark in 1998 to that in 1999?
Your response must be concise. 1.28. What is the ratio of the Aid flow (current US$) of Korea in 1998 to that in 1999?
Offer a terse response. 1.01. What is the ratio of the Aid flow (current US$) of Austria in 1998 to that in 2000?
Offer a very short reply. 1.22. What is the ratio of the Aid flow (current US$) of Korea in 1998 to that in 2000?
Ensure brevity in your answer.  1.23. What is the ratio of the Aid flow (current US$) in Austria in 1999 to that in 2000?
Provide a succinct answer. 1.3. What is the ratio of the Aid flow (current US$) in Denmark in 1999 to that in 2000?
Offer a very short reply. 0.78. What is the ratio of the Aid flow (current US$) of Korea in 1999 to that in 2000?
Offer a terse response. 1.22. What is the difference between the highest and the second highest Aid flow (current US$) in Austria?
Keep it short and to the point. 1.01e+06. What is the difference between the highest and the second highest Aid flow (current US$) in Belgium?
Ensure brevity in your answer.  1.09e+06. What is the difference between the highest and the second highest Aid flow (current US$) in Denmark?
Provide a succinct answer. 3.37e+06. What is the difference between the highest and the second highest Aid flow (current US$) of Korea?
Provide a short and direct response. 1.90e+05. What is the difference between the highest and the lowest Aid flow (current US$) of Austria?
Provide a succinct answer. 2.15e+06. What is the difference between the highest and the lowest Aid flow (current US$) in Belgium?
Your response must be concise. 3.12e+06. What is the difference between the highest and the lowest Aid flow (current US$) of Denmark?
Offer a very short reply. 1.77e+07. What is the difference between the highest and the lowest Aid flow (current US$) in Korea?
Offer a terse response. 1.89e+07. 